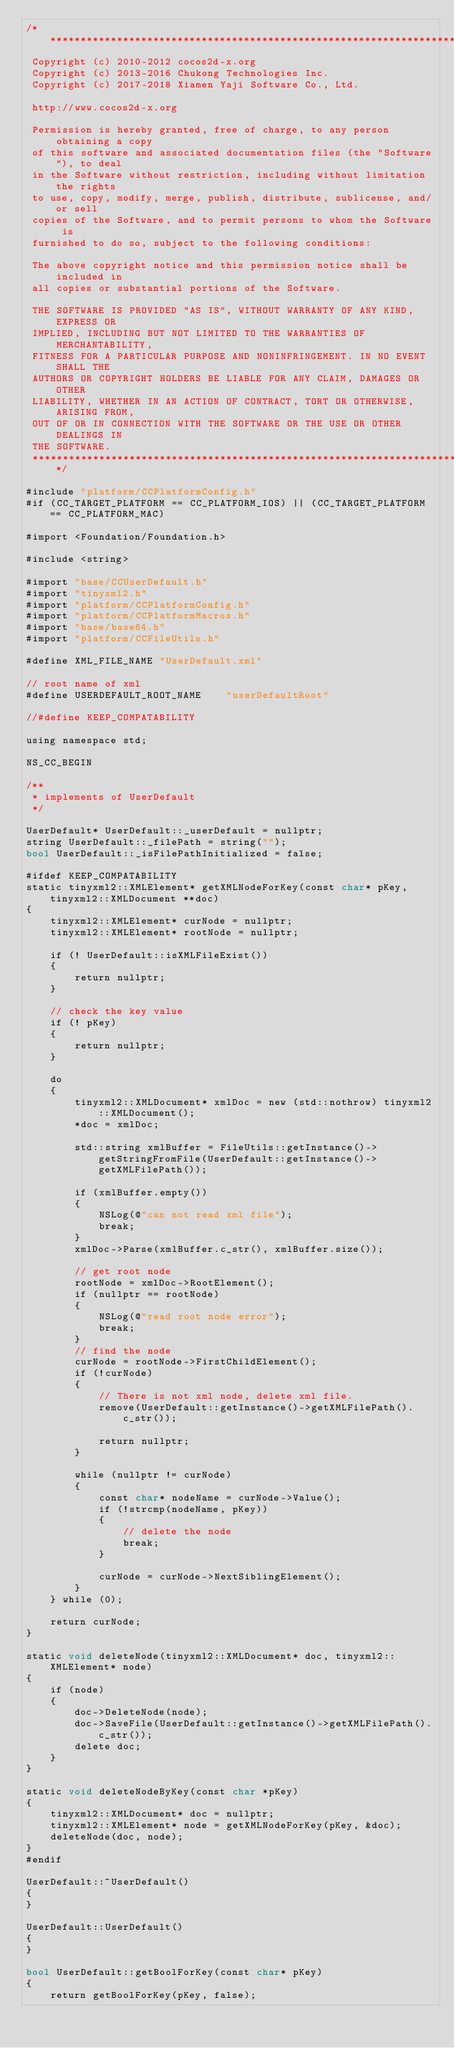<code> <loc_0><loc_0><loc_500><loc_500><_ObjectiveC_>/****************************************************************************
 Copyright (c) 2010-2012 cocos2d-x.org
 Copyright (c) 2013-2016 Chukong Technologies Inc.
 Copyright (c) 2017-2018 Xiamen Yaji Software Co., Ltd.

 http://www.cocos2d-x.org

 Permission is hereby granted, free of charge, to any person obtaining a copy
 of this software and associated documentation files (the "Software"), to deal
 in the Software without restriction, including without limitation the rights
 to use, copy, modify, merge, publish, distribute, sublicense, and/or sell
 copies of the Software, and to permit persons to whom the Software is
 furnished to do so, subject to the following conditions:

 The above copyright notice and this permission notice shall be included in
 all copies or substantial portions of the Software.

 THE SOFTWARE IS PROVIDED "AS IS", WITHOUT WARRANTY OF ANY KIND, EXPRESS OR
 IMPLIED, INCLUDING BUT NOT LIMITED TO THE WARRANTIES OF MERCHANTABILITY,
 FITNESS FOR A PARTICULAR PURPOSE AND NONINFRINGEMENT. IN NO EVENT SHALL THE
 AUTHORS OR COPYRIGHT HOLDERS BE LIABLE FOR ANY CLAIM, DAMAGES OR OTHER
 LIABILITY, WHETHER IN AN ACTION OF CONTRACT, TORT OR OTHERWISE, ARISING FROM,
 OUT OF OR IN CONNECTION WITH THE SOFTWARE OR THE USE OR OTHER DEALINGS IN
 THE SOFTWARE.
 ****************************************************************************/

#include "platform/CCPlatformConfig.h"
#if (CC_TARGET_PLATFORM == CC_PLATFORM_IOS) || (CC_TARGET_PLATFORM == CC_PLATFORM_MAC)

#import <Foundation/Foundation.h>

#include <string>

#import "base/CCUserDefault.h"
#import "tinyxml2.h"
#import "platform/CCPlatformConfig.h"
#import "platform/CCPlatformMacros.h"
#import "base/base64.h"
#import "platform/CCFileUtils.h"

#define XML_FILE_NAME "UserDefault.xml"

// root name of xml
#define USERDEFAULT_ROOT_NAME    "userDefaultRoot"

//#define KEEP_COMPATABILITY

using namespace std;

NS_CC_BEGIN

/**
 * implements of UserDefault
 */

UserDefault* UserDefault::_userDefault = nullptr;
string UserDefault::_filePath = string("");
bool UserDefault::_isFilePathInitialized = false;

#ifdef KEEP_COMPATABILITY
static tinyxml2::XMLElement* getXMLNodeForKey(const char* pKey, tinyxml2::XMLDocument **doc)
{
    tinyxml2::XMLElement* curNode = nullptr;
    tinyxml2::XMLElement* rootNode = nullptr;

    if (! UserDefault::isXMLFileExist())
    {
        return nullptr;
    }

    // check the key value
    if (! pKey)
    {
        return nullptr;
    }

    do
    {
 		tinyxml2::XMLDocument* xmlDoc = new (std::nothrow) tinyxml2::XMLDocument();
		*doc = xmlDoc;

        std::string xmlBuffer = FileUtils::getInstance()->getStringFromFile(UserDefault::getInstance()->getXMLFilePath());

		if (xmlBuffer.empty())
		{
            NSLog(@"can not read xml file");
			break;
		}
		xmlDoc->Parse(xmlBuffer.c_str(), xmlBuffer.size());

		// get root node
		rootNode = xmlDoc->RootElement();
		if (nullptr == rootNode)
		{
            NSLog(@"read root node error");
			break;
		}
		// find the node
		curNode = rootNode->FirstChildElement();
        if (!curNode)
        {
            // There is not xml node, delete xml file.
            remove(UserDefault::getInstance()->getXMLFilePath().c_str());

            return nullptr;
        }

		while (nullptr != curNode)
		{
			const char* nodeName = curNode->Value();
			if (!strcmp(nodeName, pKey))
			{
                // delete the node
				break;
			}

			curNode = curNode->NextSiblingElement();
		}
	} while (0);

	return curNode;
}

static void deleteNode(tinyxml2::XMLDocument* doc, tinyxml2::XMLElement* node)
{
    if (node)
    {
        doc->DeleteNode(node);
        doc->SaveFile(UserDefault::getInstance()->getXMLFilePath().c_str());
        delete doc;
    }
}

static void deleteNodeByKey(const char *pKey)
{
    tinyxml2::XMLDocument* doc = nullptr;
    tinyxml2::XMLElement* node = getXMLNodeForKey(pKey, &doc);
    deleteNode(doc, node);
}
#endif

UserDefault::~UserDefault()
{
}

UserDefault::UserDefault()
{
}

bool UserDefault::getBoolForKey(const char* pKey)
{
    return getBoolForKey(pKey, false);</code> 